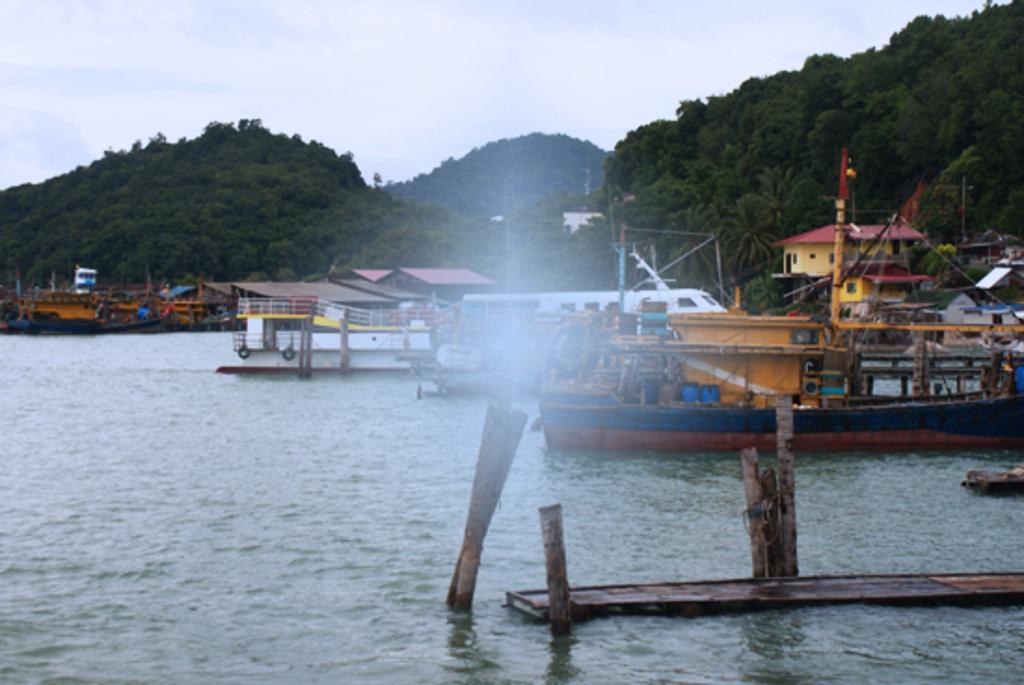Describe this image in one or two sentences. In the center of the image there is a lake and we can see ships on the lake. In the background there are hills and sky. 